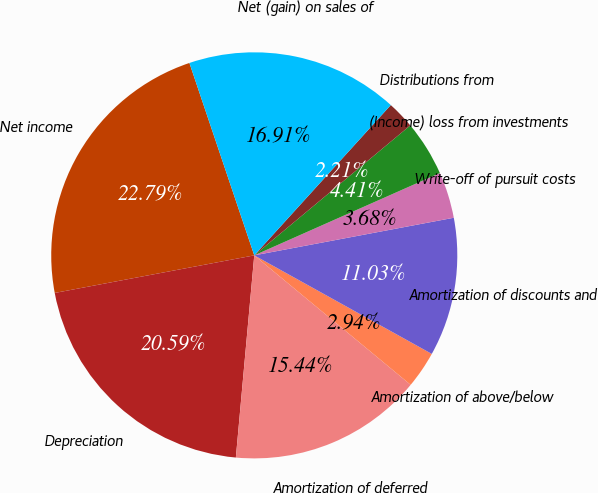Convert chart. <chart><loc_0><loc_0><loc_500><loc_500><pie_chart><fcel>Net income<fcel>Depreciation<fcel>Amortization of deferred<fcel>Amortization of above/below<fcel>Amortization of discounts and<fcel>Write-off of pursuit costs<fcel>(Income) loss from investments<fcel>Distributions from<fcel>Net (gain) on sales of<nl><fcel>22.79%<fcel>20.59%<fcel>15.44%<fcel>2.94%<fcel>11.03%<fcel>3.68%<fcel>4.41%<fcel>2.21%<fcel>16.91%<nl></chart> 